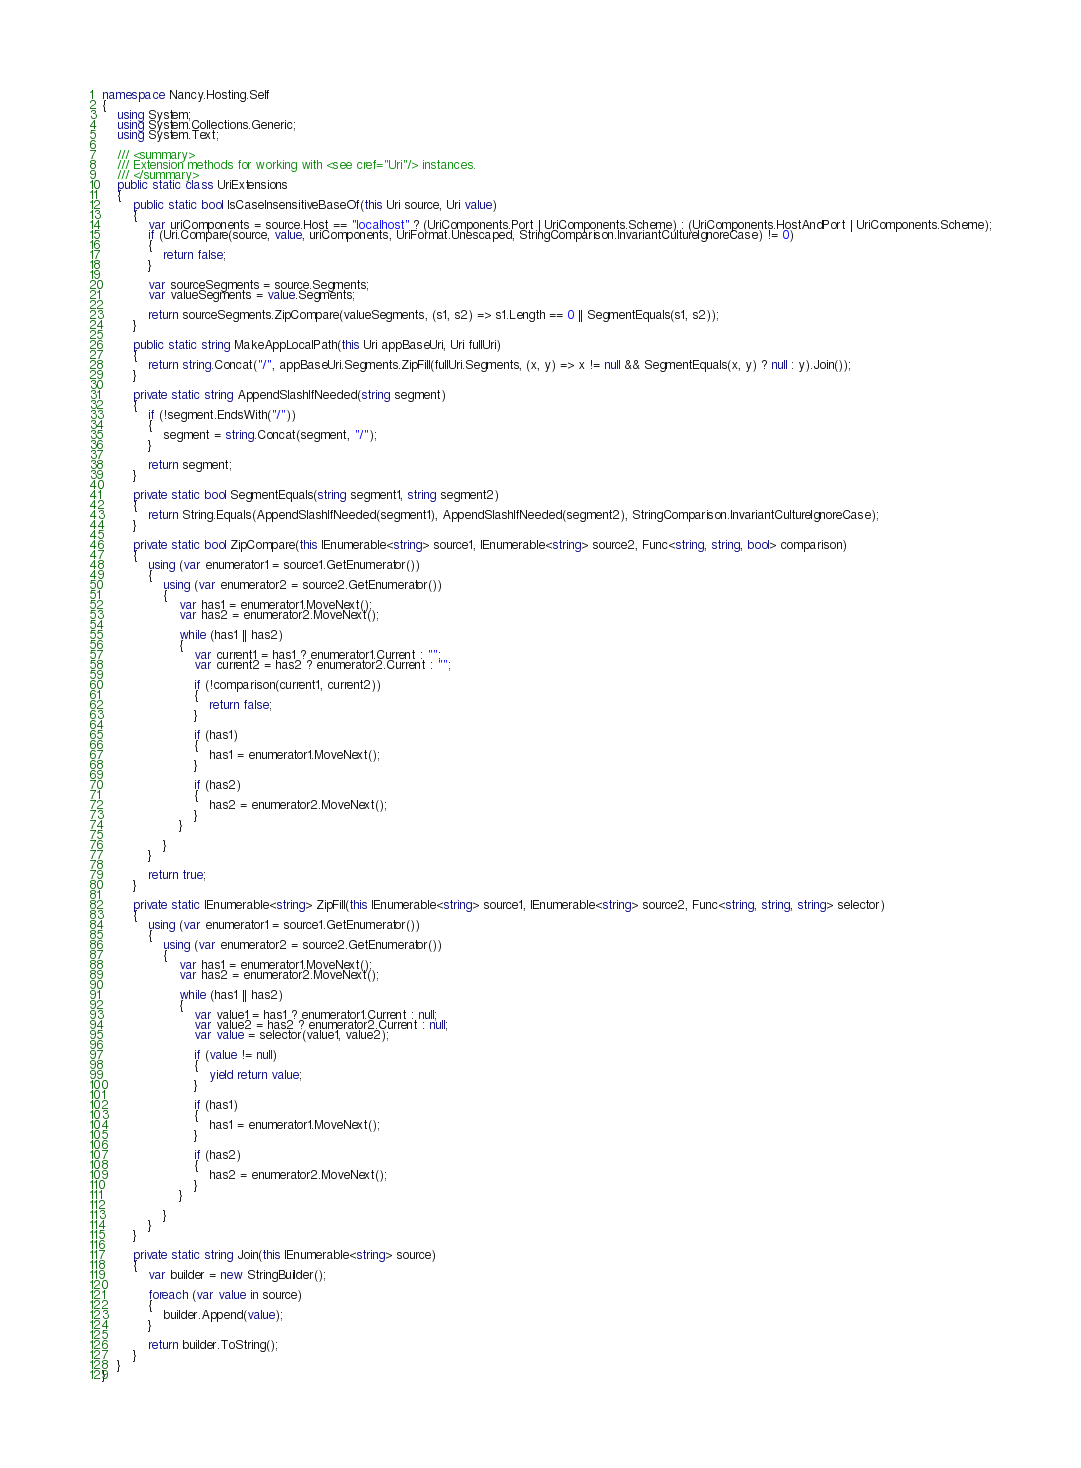<code> <loc_0><loc_0><loc_500><loc_500><_C#_>namespace Nancy.Hosting.Self
{
    using System;
    using System.Collections.Generic;
    using System.Text;

    /// <summary>
    /// Extension methods for working with <see cref="Uri"/> instances.
    /// </summary>
    public static class UriExtensions
    {
        public static bool IsCaseInsensitiveBaseOf(this Uri source, Uri value)
        {
            var uriComponents = source.Host == "localhost" ? (UriComponents.Port | UriComponents.Scheme) : (UriComponents.HostAndPort | UriComponents.Scheme);
            if (Uri.Compare(source, value, uriComponents, UriFormat.Unescaped, StringComparison.InvariantCultureIgnoreCase) != 0)
            {
                return false;
            }

            var sourceSegments = source.Segments;
            var valueSegments = value.Segments;

            return sourceSegments.ZipCompare(valueSegments, (s1, s2) => s1.Length == 0 || SegmentEquals(s1, s2));
        }

        public static string MakeAppLocalPath(this Uri appBaseUri, Uri fullUri)
        {
            return string.Concat("/", appBaseUri.Segments.ZipFill(fullUri.Segments, (x, y) => x != null && SegmentEquals(x, y) ? null : y).Join());
        }

        private static string AppendSlashIfNeeded(string segment)
        {
            if (!segment.EndsWith("/"))
            {
                segment = string.Concat(segment, "/");
            }

            return segment;
        }

        private static bool SegmentEquals(string segment1, string segment2)
        {
            return String.Equals(AppendSlashIfNeeded(segment1), AppendSlashIfNeeded(segment2), StringComparison.InvariantCultureIgnoreCase);
        }

        private static bool ZipCompare(this IEnumerable<string> source1, IEnumerable<string> source2, Func<string, string, bool> comparison)
        {
            using (var enumerator1 = source1.GetEnumerator())
            {
                using (var enumerator2 = source2.GetEnumerator())
                {
                    var has1 = enumerator1.MoveNext();
                    var has2 = enumerator2.MoveNext();

                    while (has1 || has2)
                    {
                        var current1 = has1 ? enumerator1.Current : "";
                        var current2 = has2 ? enumerator2.Current : "";

                        if (!comparison(current1, current2))
                        {
                            return false;
                        }

                        if (has1)
                        {
                            has1 = enumerator1.MoveNext();
                        }

                        if (has2)
                        {
                            has2 = enumerator2.MoveNext();
                        }
                    }

                }
            }

            return true;
        }

        private static IEnumerable<string> ZipFill(this IEnumerable<string> source1, IEnumerable<string> source2, Func<string, string, string> selector)
        {
            using (var enumerator1 = source1.GetEnumerator())
            {
                using (var enumerator2 = source2.GetEnumerator())
                {
                    var has1 = enumerator1.MoveNext();
                    var has2 = enumerator2.MoveNext();

                    while (has1 || has2)
                    {
                        var value1 = has1 ? enumerator1.Current : null;
                        var value2 = has2 ? enumerator2.Current : null;
                        var value = selector(value1, value2);

                        if (value != null)
                        {
                            yield return value;
                        }

                        if (has1)
                        {
                            has1 = enumerator1.MoveNext();
                        }

                        if (has2)
                        {
                            has2 = enumerator2.MoveNext();
                        }
                    }

                }
            }
        }

        private static string Join(this IEnumerable<string> source)
        {
            var builder = new StringBuilder();

            foreach (var value in source)
            {
                builder.Append(value);
            }

            return builder.ToString();
        }
    }
}
</code> 